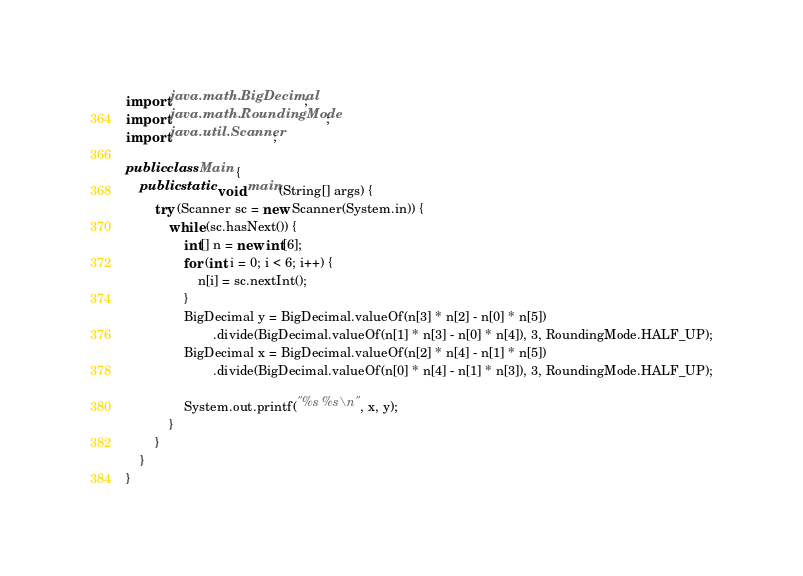<code> <loc_0><loc_0><loc_500><loc_500><_Java_>import java.math.BigDecimal;
import java.math.RoundingMode;
import java.util.Scanner;

public class Main {
	public static void main(String[] args) {
		try (Scanner sc = new Scanner(System.in)) {
			while (sc.hasNext()) {
				int[] n = new int[6];
				for (int i = 0; i < 6; i++) {
					n[i] = sc.nextInt();
				}
				BigDecimal y = BigDecimal.valueOf(n[3] * n[2] - n[0] * n[5])
						.divide(BigDecimal.valueOf(n[1] * n[3] - n[0] * n[4]), 3, RoundingMode.HALF_UP);
				BigDecimal x = BigDecimal.valueOf(n[2] * n[4] - n[1] * n[5])
						.divide(BigDecimal.valueOf(n[0] * n[4] - n[1] * n[3]), 3, RoundingMode.HALF_UP);

				System.out.printf("%s %s\n", x, y);
			}
		}
	}
}</code> 